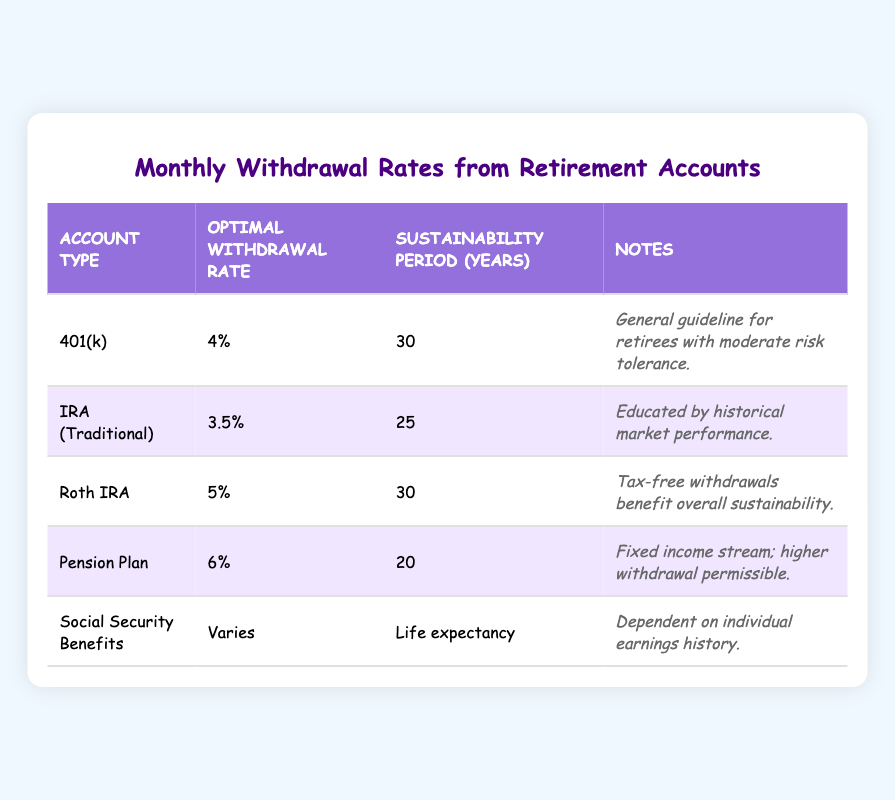What is the optimal withdrawal rate for a Roth IRA? The table shows that the optimal withdrawal rate for a Roth IRA is listed as 5%.
Answer: 5% How many years can one sustain withdrawals at the optimal rate from a pension plan? According to the table, the sustainability period for a pension plan at the optimal withdrawal rate of 6% is 20 years.
Answer: 20 years Is the optimal withdrawal rate for an IRA (Traditional) higher than that of a 401(k)? The table states that the optimal withdrawal rate for an IRA (Traditional) is 3.5%, while for a 401(k) it is 4%, making the IRA's rate lower.
Answer: No What is the average optimal withdrawal rate for all account types listed? To find the average, sum the rates (4 + 3.5 + 5 + 6) = 18.5, divide by the count (4) = 18.5/4 = 4.625. Note that Social Security varies and is not included.
Answer: 4.625% Which account type allows for the highest optimal withdrawal rate? Looking at the table, the account type with the highest optimal withdrawal rate is the Pension Plan at 6%.
Answer: Pension Plan How many years of sustainability does the Roth IRA provide compared to the IRA (Traditional)? The Roth IRA has a sustainability period of 30 years, whereas the IRA (Traditional) has 25 years. The difference is 30 - 25 = 5 years, meaning the Roth IRA has 5 more years of sustainability.
Answer: 5 years Is it true that Social Security Benefits have a fixed optimal withdrawal rate? According to the table, Social Security Benefits have a withdrawal rate that varies and is dependent on individual earnings history, indicating it is not fixed.
Answer: No What is the difference in sustainability years between the Roth IRA and the Pension Plan? The Roth IRA allows for withdrawals for 30 years, while the Pension Plan allows for 20 years. The difference is 30 - 20 = 10 years, so the Roth IRA provides 10 more years of sustainability.
Answer: 10 years What notes are associated with the optimal withdrawal rate of a 401(k)? The notes for the 401(k) state: "General guideline for retirees with moderate risk tolerance."
Answer: General guideline for retirees with moderate risk tolerance 